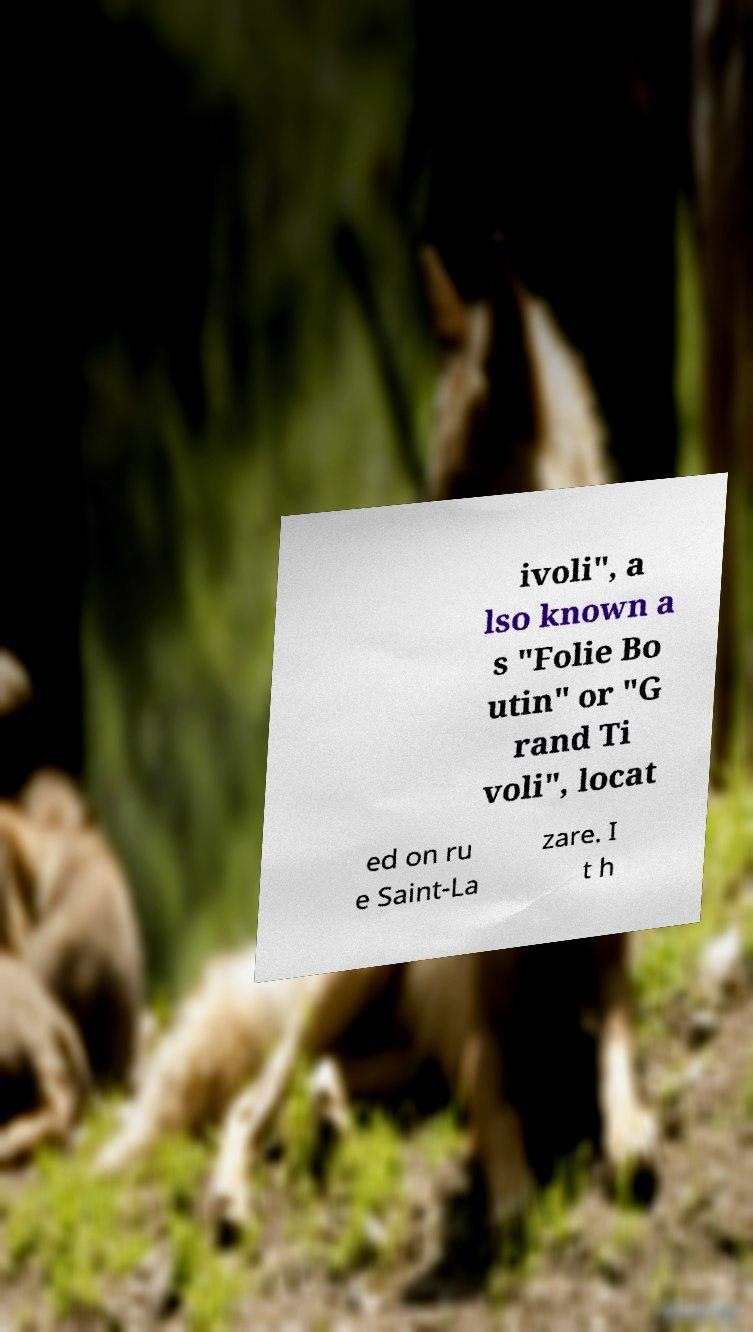Please identify and transcribe the text found in this image. ivoli", a lso known a s "Folie Bo utin" or "G rand Ti voli", locat ed on ru e Saint-La zare. I t h 